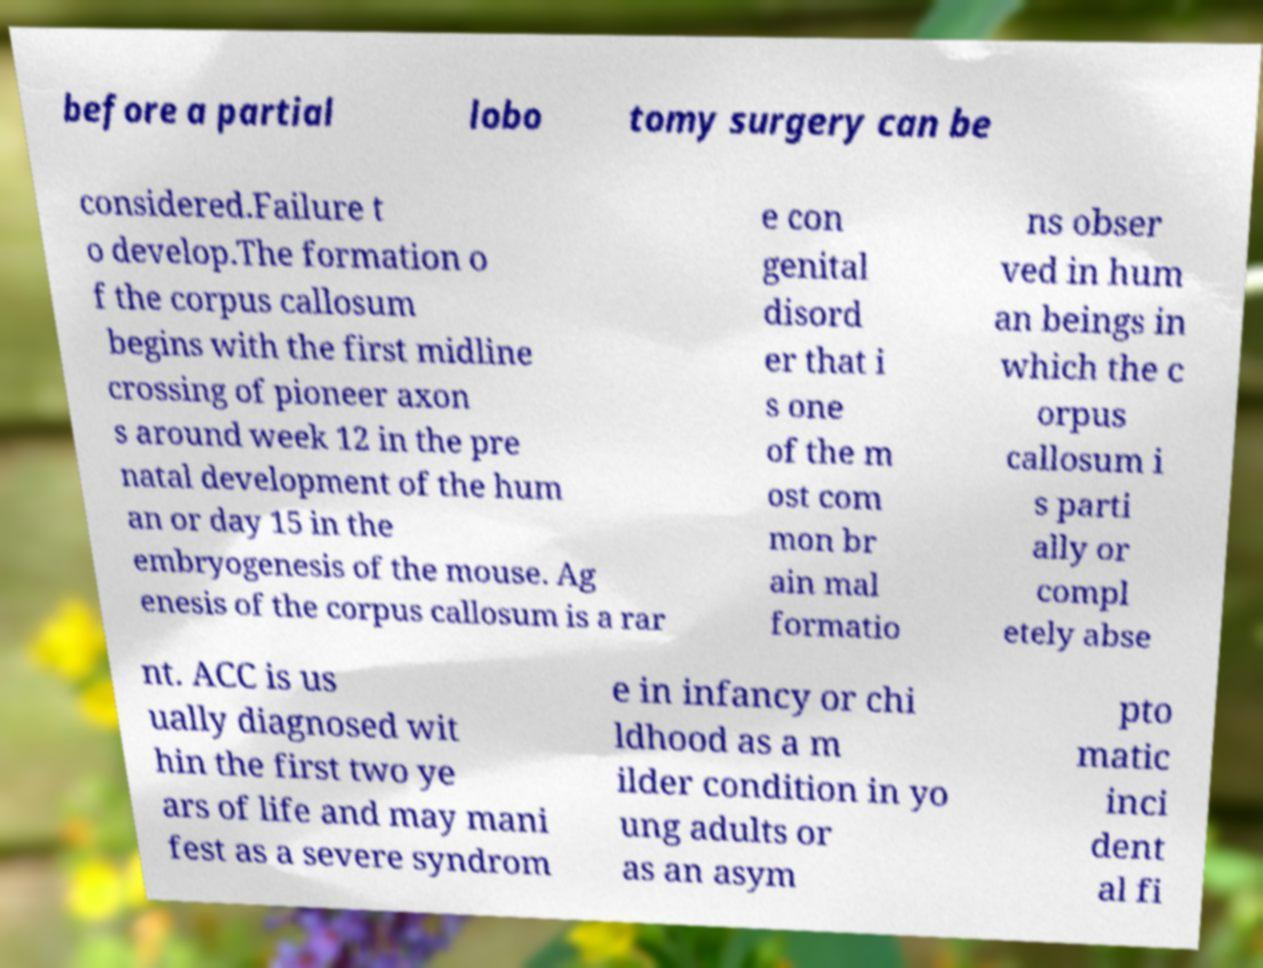Could you assist in decoding the text presented in this image and type it out clearly? before a partial lobo tomy surgery can be considered.Failure t o develop.The formation o f the corpus callosum begins with the first midline crossing of pioneer axon s around week 12 in the pre natal development of the hum an or day 15 in the embryogenesis of the mouse. Ag enesis of the corpus callosum is a rar e con genital disord er that i s one of the m ost com mon br ain mal formatio ns obser ved in hum an beings in which the c orpus callosum i s parti ally or compl etely abse nt. ACC is us ually diagnosed wit hin the first two ye ars of life and may mani fest as a severe syndrom e in infancy or chi ldhood as a m ilder condition in yo ung adults or as an asym pto matic inci dent al fi 